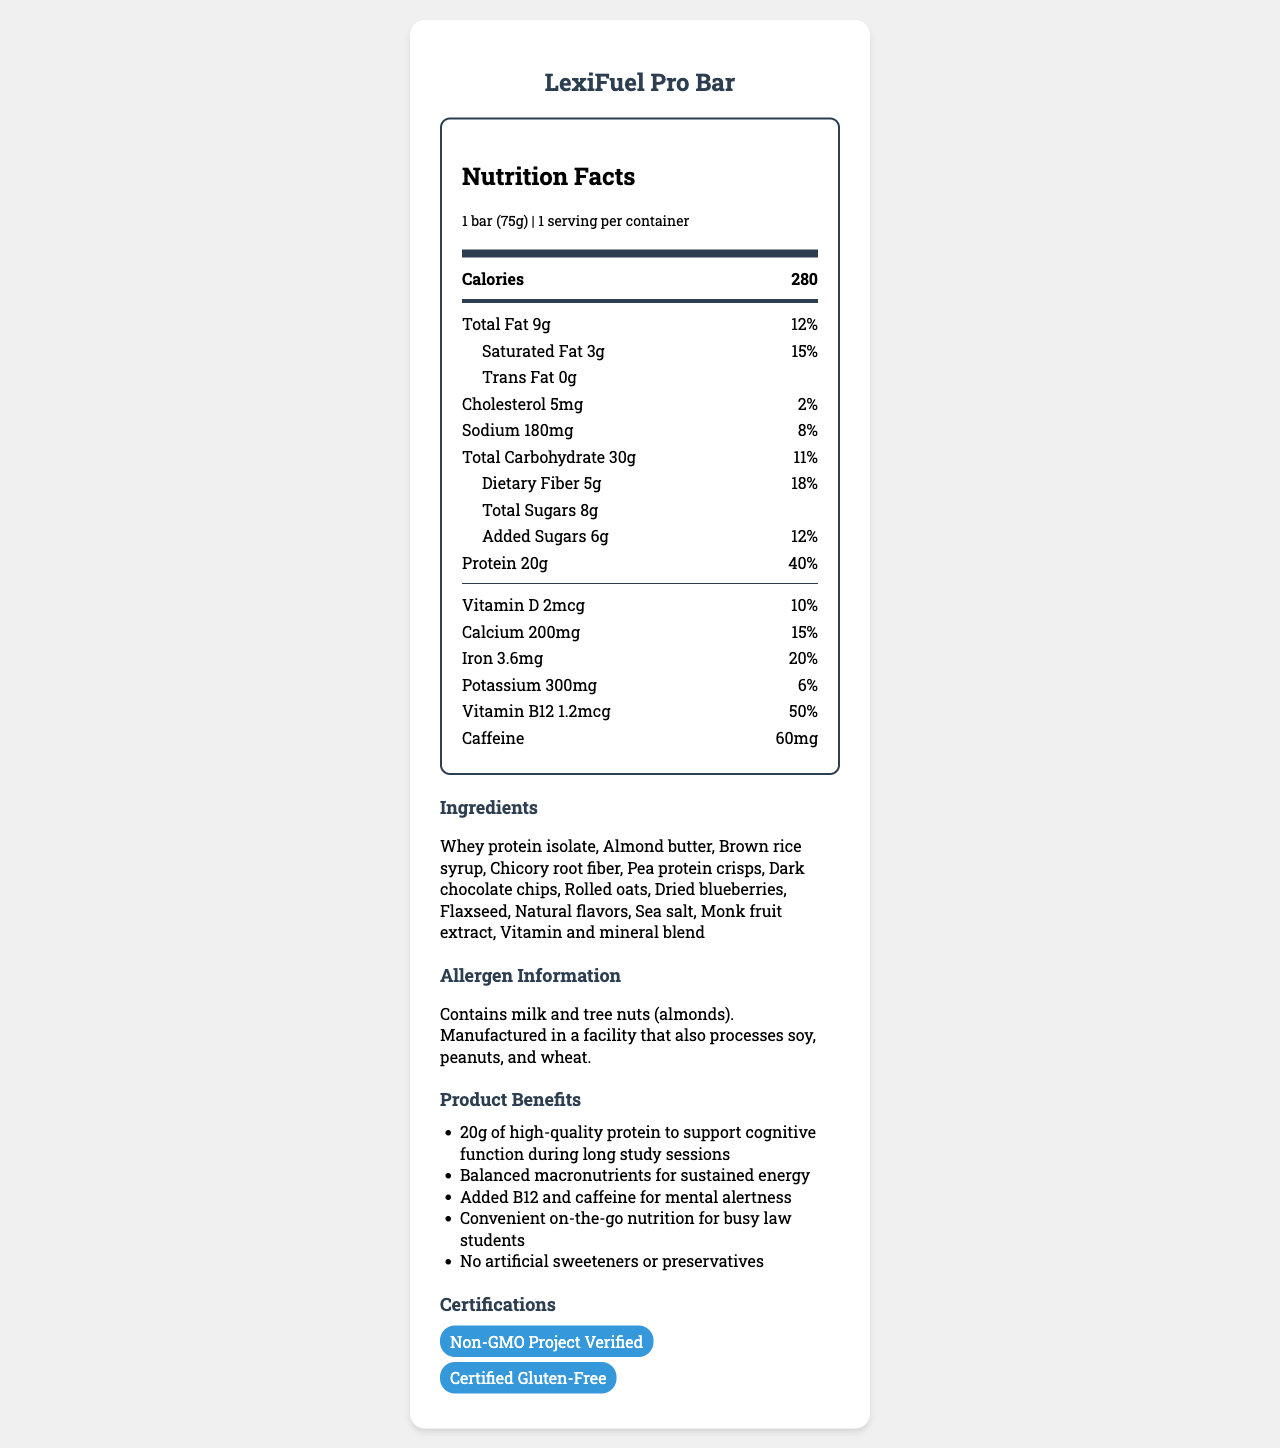what is the product name? The product name is clearly stated at the top of the document as "LexiFuel Pro Bar".
Answer: LexiFuel Pro Bar what is the serving size of the LexiFuel Pro Bar? The serving size is specified in the nutrition facts section of the document as "1 bar (75g)".
Answer: 1 bar (75g) how many calories are in one LexiFuel Pro Bar? According to the nutrition label, one LexiFuel Pro Bar contains 280 calories.
Answer: 280 how much protein is in a LexiFuel Pro Bar? The nutrition facts section details that each bar contains 20 grams of protein.
Answer: 20g what are the main ingredients in the LexiFuel Pro Bar? The ingredients are listed in the ingredients section of the document.
Answer: Whey protein isolate, Almond butter, Brown rice syrup, Chicory root fiber, Pea protein crisps, Dark chocolate chips, Rolled oats, Dried blueberries, Flaxseed, Natural flavors, Sea salt, Monk fruit extract, Vitamin and mineral blend which of these claims is made about the LexiFuel Pro Bar? A. No sugar B. High in protein C. Contains soy D. Less than 100 calories The bar is marketed as having "20g of high-quality protein to support cognitive function during long study sessions" which indicates it is high in protein.
Answer: B how much dietary fiber does the LexiFuel Pro Bar have? The nutrition label states that the bar has 5 grams of dietary fiber.
Answer: 5g what percentage of the daily value of iron does the LexiFuel Pro Bar provide? A. 10% B. 15% C. 20% D. 25% The nutrition label indicates that the bar provides 20% of the daily value of iron.
Answer: C is the LexiFuel Pro Bar gluten-free? The bar is certified gluten-free as mentioned in the certifications section.
Answer: Yes does the LexiFuel Pro Bar contain artificial sweeteners? The marketing claims section specifies that the bar has "No artificial sweeteners or preservatives".
Answer: No how much caffeine is in a LexiFuel Pro Bar? The nutrition label indicates that the bar contains 60mg of caffeine.
Answer: 60mg what is the calcium content per serving in the LexiFuel Pro Bar? The document specifies that the bar contains 200mg of calcium per serving.
Answer: 200mg describe the main idea of the document The document serves as a comprehensive guide to understanding the nutritional value, ingredients, and specific benefits of the LexiFuel Pro Bar.
Answer: The document provides detailed nutrition facts, ingredient information, marketing claims, and certifications for the LexiFuel Pro Bar, which is a high-protein meal replacement bar designed for law students. It highlights the bar's nutritional content, allergen information, and benefits to support cognitive function and energy levels during long study sessions. how much total fat is in the LexiFuel Pro Bar? The nutrition facts section states that the bar contains 9 grams of total fat.
Answer: 9g does the LexiFuel Pro Bar contain peanuts? The allergen information specifies that while the bar contains milk and tree nuts (almonds), it is manufactured in a facility that also processes peanuts.
Answer: Not necessarily, but it is manufactured in a facility that processes peanuts. what is the total carbohydrate content in the LexiFuel Pro Bar? The nutrition label indicates that the total carbohydrate content is 30 grams.
Answer: 30g how much added sugars does the LexiFuel Pro Bar have? The nutrition facts section specifies that the bar contains 6 grams of added sugars.
Answer: 6g what certifications does the LexiFuel Pro Bar have? The certifications section lists that the bar is Non-GMO Project Verified and Certified Gluten-Free.
Answer: Non-GMO Project Verified, Certified Gluten-Free is the LexiFuel Pro Bar suitable for vegans? The document does not provide information about whether the bar is suitable for vegans. It contains whey protein isolate, which is a milk-derived protein and would not be vegan, but other possible non-vegan ingredients are not specified.
Answer: Cannot be determined 